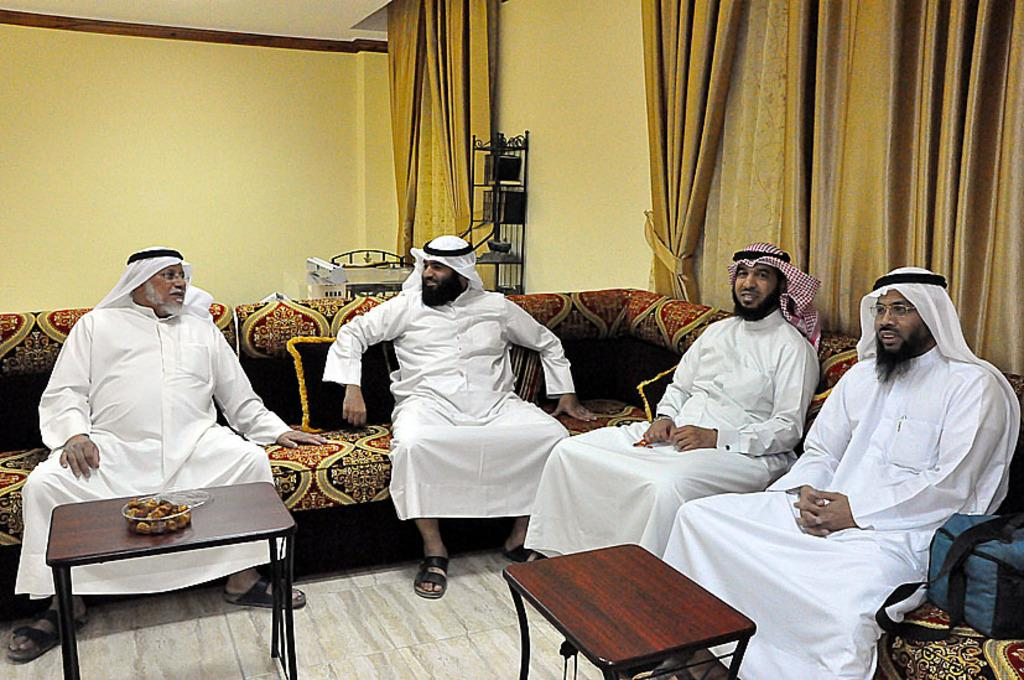How many men are in the image? There are four men in the image. What are the men doing in the image? The men are sitting on a sofa. What are the men wearing in the image? The men are wearing white-colored dresses. What can be seen on the table in the image? There is food on the table. What is present on the right side of the image? There are curtains on the right side of the image. Where are the curtains located in the image? The curtains are on the walls. What type of insurance policy do the men discuss while sitting on the sofa? There is no indication in the image that the men are discussing any insurance policies. 